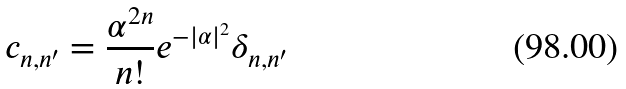<formula> <loc_0><loc_0><loc_500><loc_500>c _ { n , n ^ { \prime } } = \frac { \alpha ^ { 2 n } } { n ! } e ^ { - | \alpha | ^ { 2 } } \delta _ { n , n ^ { \prime } }</formula> 